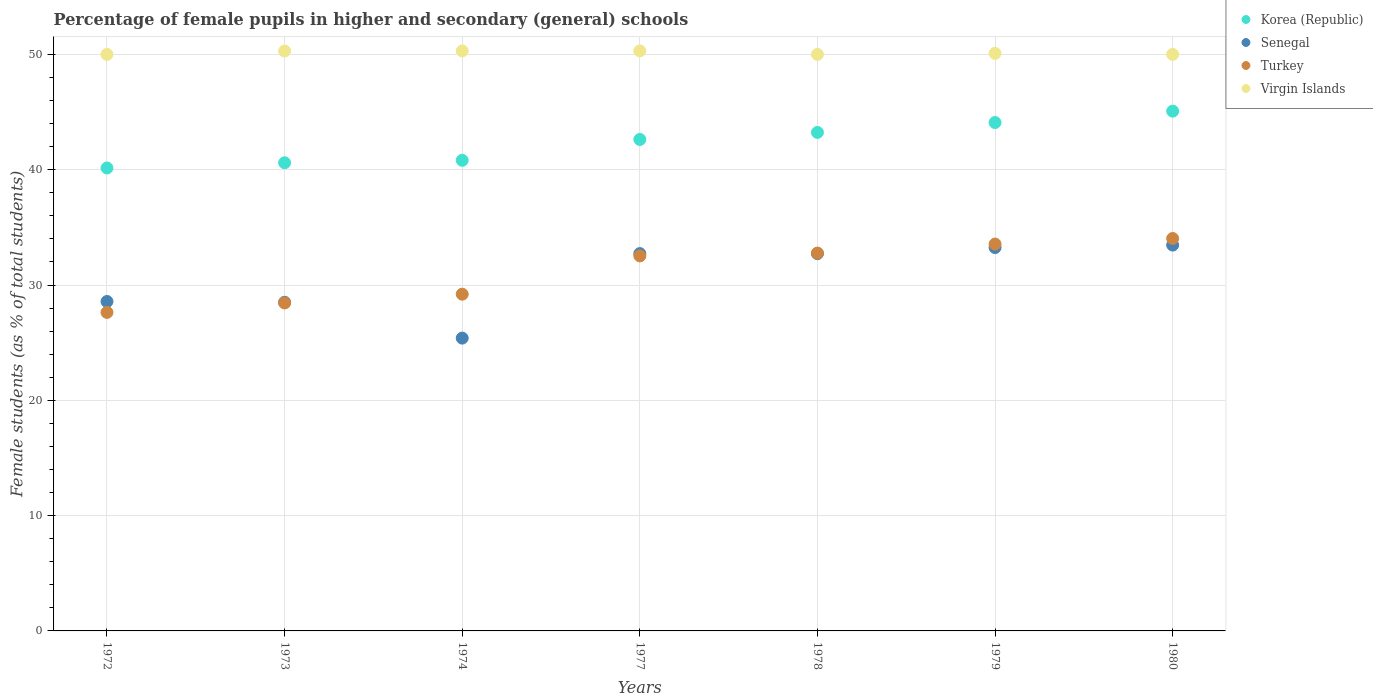What is the percentage of female pupils in higher and secondary schools in Korea (Republic) in 1980?
Your answer should be compact. 45.08. Across all years, what is the maximum percentage of female pupils in higher and secondary schools in Virgin Islands?
Make the answer very short. 50.3. Across all years, what is the minimum percentage of female pupils in higher and secondary schools in Turkey?
Keep it short and to the point. 27.62. In which year was the percentage of female pupils in higher and secondary schools in Virgin Islands maximum?
Your answer should be compact. 1977. In which year was the percentage of female pupils in higher and secondary schools in Senegal minimum?
Your response must be concise. 1974. What is the total percentage of female pupils in higher and secondary schools in Virgin Islands in the graph?
Provide a succinct answer. 350.99. What is the difference between the percentage of female pupils in higher and secondary schools in Turkey in 1974 and that in 1980?
Ensure brevity in your answer.  -4.83. What is the difference between the percentage of female pupils in higher and secondary schools in Senegal in 1978 and the percentage of female pupils in higher and secondary schools in Korea (Republic) in 1980?
Provide a short and direct response. -12.36. What is the average percentage of female pupils in higher and secondary schools in Senegal per year?
Ensure brevity in your answer.  30.66. In the year 1973, what is the difference between the percentage of female pupils in higher and secondary schools in Virgin Islands and percentage of female pupils in higher and secondary schools in Turkey?
Provide a succinct answer. 21.85. What is the ratio of the percentage of female pupils in higher and secondary schools in Senegal in 1973 to that in 1980?
Provide a short and direct response. 0.85. What is the difference between the highest and the second highest percentage of female pupils in higher and secondary schools in Turkey?
Ensure brevity in your answer.  0.48. What is the difference between the highest and the lowest percentage of female pupils in higher and secondary schools in Turkey?
Make the answer very short. 6.41. Does the percentage of female pupils in higher and secondary schools in Korea (Republic) monotonically increase over the years?
Your answer should be very brief. Yes. Is the percentage of female pupils in higher and secondary schools in Senegal strictly greater than the percentage of female pupils in higher and secondary schools in Turkey over the years?
Your answer should be very brief. No. Is the percentage of female pupils in higher and secondary schools in Turkey strictly less than the percentage of female pupils in higher and secondary schools in Senegal over the years?
Provide a short and direct response. No. How many dotlines are there?
Offer a very short reply. 4. How many years are there in the graph?
Offer a terse response. 7. Does the graph contain grids?
Your response must be concise. Yes. Where does the legend appear in the graph?
Provide a succinct answer. Top right. How many legend labels are there?
Your answer should be compact. 4. How are the legend labels stacked?
Your answer should be compact. Vertical. What is the title of the graph?
Offer a terse response. Percentage of female pupils in higher and secondary (general) schools. What is the label or title of the Y-axis?
Your response must be concise. Female students (as % of total students). What is the Female students (as % of total students) in Korea (Republic) in 1972?
Your response must be concise. 40.15. What is the Female students (as % of total students) of Senegal in 1972?
Offer a very short reply. 28.57. What is the Female students (as % of total students) of Turkey in 1972?
Provide a short and direct response. 27.62. What is the Female students (as % of total students) in Korea (Republic) in 1973?
Offer a very short reply. 40.6. What is the Female students (as % of total students) of Senegal in 1973?
Provide a succinct answer. 28.5. What is the Female students (as % of total students) of Turkey in 1973?
Offer a terse response. 28.45. What is the Female students (as % of total students) in Virgin Islands in 1973?
Your answer should be compact. 50.3. What is the Female students (as % of total students) of Korea (Republic) in 1974?
Offer a terse response. 40.82. What is the Female students (as % of total students) of Senegal in 1974?
Give a very brief answer. 25.39. What is the Female students (as % of total students) in Turkey in 1974?
Provide a short and direct response. 29.2. What is the Female students (as % of total students) of Virgin Islands in 1974?
Ensure brevity in your answer.  50.3. What is the Female students (as % of total students) in Korea (Republic) in 1977?
Offer a terse response. 42.62. What is the Female students (as % of total students) in Senegal in 1977?
Give a very brief answer. 32.72. What is the Female students (as % of total students) in Turkey in 1977?
Offer a terse response. 32.52. What is the Female students (as % of total students) in Virgin Islands in 1977?
Your response must be concise. 50.3. What is the Female students (as % of total students) in Korea (Republic) in 1978?
Keep it short and to the point. 43.23. What is the Female students (as % of total students) of Senegal in 1978?
Ensure brevity in your answer.  32.72. What is the Female students (as % of total students) in Turkey in 1978?
Your response must be concise. 32.77. What is the Female students (as % of total students) in Korea (Republic) in 1979?
Your answer should be very brief. 44.09. What is the Female students (as % of total students) in Senegal in 1979?
Your answer should be compact. 33.25. What is the Female students (as % of total students) of Turkey in 1979?
Keep it short and to the point. 33.55. What is the Female students (as % of total students) in Virgin Islands in 1979?
Your answer should be compact. 50.09. What is the Female students (as % of total students) in Korea (Republic) in 1980?
Ensure brevity in your answer.  45.08. What is the Female students (as % of total students) in Senegal in 1980?
Give a very brief answer. 33.46. What is the Female students (as % of total students) of Turkey in 1980?
Provide a short and direct response. 34.03. What is the Female students (as % of total students) of Virgin Islands in 1980?
Give a very brief answer. 50. Across all years, what is the maximum Female students (as % of total students) in Korea (Republic)?
Make the answer very short. 45.08. Across all years, what is the maximum Female students (as % of total students) in Senegal?
Ensure brevity in your answer.  33.46. Across all years, what is the maximum Female students (as % of total students) in Turkey?
Ensure brevity in your answer.  34.03. Across all years, what is the maximum Female students (as % of total students) of Virgin Islands?
Provide a short and direct response. 50.3. Across all years, what is the minimum Female students (as % of total students) of Korea (Republic)?
Keep it short and to the point. 40.15. Across all years, what is the minimum Female students (as % of total students) of Senegal?
Provide a short and direct response. 25.39. Across all years, what is the minimum Female students (as % of total students) in Turkey?
Your response must be concise. 27.62. What is the total Female students (as % of total students) of Korea (Republic) in the graph?
Offer a very short reply. 296.59. What is the total Female students (as % of total students) in Senegal in the graph?
Provide a short and direct response. 214.62. What is the total Female students (as % of total students) in Turkey in the graph?
Provide a short and direct response. 218.15. What is the total Female students (as % of total students) in Virgin Islands in the graph?
Ensure brevity in your answer.  350.99. What is the difference between the Female students (as % of total students) in Korea (Republic) in 1972 and that in 1973?
Your answer should be very brief. -0.45. What is the difference between the Female students (as % of total students) in Senegal in 1972 and that in 1973?
Offer a very short reply. 0.07. What is the difference between the Female students (as % of total students) in Turkey in 1972 and that in 1973?
Your answer should be very brief. -0.82. What is the difference between the Female students (as % of total students) of Virgin Islands in 1972 and that in 1973?
Provide a short and direct response. -0.3. What is the difference between the Female students (as % of total students) of Korea (Republic) in 1972 and that in 1974?
Offer a terse response. -0.67. What is the difference between the Female students (as % of total students) in Senegal in 1972 and that in 1974?
Keep it short and to the point. 3.18. What is the difference between the Female students (as % of total students) in Turkey in 1972 and that in 1974?
Give a very brief answer. -1.58. What is the difference between the Female students (as % of total students) in Virgin Islands in 1972 and that in 1974?
Keep it short and to the point. -0.3. What is the difference between the Female students (as % of total students) in Korea (Republic) in 1972 and that in 1977?
Ensure brevity in your answer.  -2.47. What is the difference between the Female students (as % of total students) of Senegal in 1972 and that in 1977?
Make the answer very short. -4.15. What is the difference between the Female students (as % of total students) of Turkey in 1972 and that in 1977?
Ensure brevity in your answer.  -4.9. What is the difference between the Female students (as % of total students) of Virgin Islands in 1972 and that in 1977?
Offer a very short reply. -0.3. What is the difference between the Female students (as % of total students) of Korea (Republic) in 1972 and that in 1978?
Offer a terse response. -3.08. What is the difference between the Female students (as % of total students) of Senegal in 1972 and that in 1978?
Your answer should be compact. -4.15. What is the difference between the Female students (as % of total students) of Turkey in 1972 and that in 1978?
Make the answer very short. -5.14. What is the difference between the Female students (as % of total students) of Korea (Republic) in 1972 and that in 1979?
Give a very brief answer. -3.94. What is the difference between the Female students (as % of total students) in Senegal in 1972 and that in 1979?
Your answer should be compact. -4.68. What is the difference between the Female students (as % of total students) in Turkey in 1972 and that in 1979?
Offer a very short reply. -5.93. What is the difference between the Female students (as % of total students) of Virgin Islands in 1972 and that in 1979?
Your response must be concise. -0.09. What is the difference between the Female students (as % of total students) of Korea (Republic) in 1972 and that in 1980?
Give a very brief answer. -4.93. What is the difference between the Female students (as % of total students) of Senegal in 1972 and that in 1980?
Provide a succinct answer. -4.89. What is the difference between the Female students (as % of total students) in Turkey in 1972 and that in 1980?
Your answer should be compact. -6.41. What is the difference between the Female students (as % of total students) of Korea (Republic) in 1973 and that in 1974?
Your response must be concise. -0.21. What is the difference between the Female students (as % of total students) of Senegal in 1973 and that in 1974?
Give a very brief answer. 3.11. What is the difference between the Female students (as % of total students) in Turkey in 1973 and that in 1974?
Offer a terse response. -0.76. What is the difference between the Female students (as % of total students) in Virgin Islands in 1973 and that in 1974?
Your response must be concise. -0. What is the difference between the Female students (as % of total students) of Korea (Republic) in 1973 and that in 1977?
Make the answer very short. -2.02. What is the difference between the Female students (as % of total students) of Senegal in 1973 and that in 1977?
Your response must be concise. -4.22. What is the difference between the Female students (as % of total students) in Turkey in 1973 and that in 1977?
Provide a succinct answer. -4.08. What is the difference between the Female students (as % of total students) of Virgin Islands in 1973 and that in 1977?
Make the answer very short. -0. What is the difference between the Female students (as % of total students) in Korea (Republic) in 1973 and that in 1978?
Provide a succinct answer. -2.63. What is the difference between the Female students (as % of total students) in Senegal in 1973 and that in 1978?
Keep it short and to the point. -4.22. What is the difference between the Female students (as % of total students) in Turkey in 1973 and that in 1978?
Offer a very short reply. -4.32. What is the difference between the Female students (as % of total students) of Virgin Islands in 1973 and that in 1978?
Offer a terse response. 0.3. What is the difference between the Female students (as % of total students) in Korea (Republic) in 1973 and that in 1979?
Your answer should be very brief. -3.49. What is the difference between the Female students (as % of total students) of Senegal in 1973 and that in 1979?
Your response must be concise. -4.75. What is the difference between the Female students (as % of total students) of Turkey in 1973 and that in 1979?
Offer a terse response. -5.11. What is the difference between the Female students (as % of total students) in Virgin Islands in 1973 and that in 1979?
Provide a succinct answer. 0.2. What is the difference between the Female students (as % of total students) of Korea (Republic) in 1973 and that in 1980?
Ensure brevity in your answer.  -4.48. What is the difference between the Female students (as % of total students) of Senegal in 1973 and that in 1980?
Your response must be concise. -4.96. What is the difference between the Female students (as % of total students) of Turkey in 1973 and that in 1980?
Give a very brief answer. -5.59. What is the difference between the Female students (as % of total students) in Virgin Islands in 1973 and that in 1980?
Keep it short and to the point. 0.3. What is the difference between the Female students (as % of total students) in Korea (Republic) in 1974 and that in 1977?
Your answer should be very brief. -1.81. What is the difference between the Female students (as % of total students) of Senegal in 1974 and that in 1977?
Offer a very short reply. -7.33. What is the difference between the Female students (as % of total students) of Turkey in 1974 and that in 1977?
Keep it short and to the point. -3.32. What is the difference between the Female students (as % of total students) of Virgin Islands in 1974 and that in 1977?
Give a very brief answer. -0. What is the difference between the Female students (as % of total students) of Korea (Republic) in 1974 and that in 1978?
Provide a short and direct response. -2.42. What is the difference between the Female students (as % of total students) in Senegal in 1974 and that in 1978?
Offer a terse response. -7.33. What is the difference between the Female students (as % of total students) of Turkey in 1974 and that in 1978?
Ensure brevity in your answer.  -3.56. What is the difference between the Female students (as % of total students) in Virgin Islands in 1974 and that in 1978?
Your response must be concise. 0.3. What is the difference between the Female students (as % of total students) of Korea (Republic) in 1974 and that in 1979?
Make the answer very short. -3.28. What is the difference between the Female students (as % of total students) in Senegal in 1974 and that in 1979?
Provide a succinct answer. -7.85. What is the difference between the Female students (as % of total students) in Turkey in 1974 and that in 1979?
Your response must be concise. -4.35. What is the difference between the Female students (as % of total students) of Virgin Islands in 1974 and that in 1979?
Offer a terse response. 0.21. What is the difference between the Female students (as % of total students) of Korea (Republic) in 1974 and that in 1980?
Ensure brevity in your answer.  -4.26. What is the difference between the Female students (as % of total students) of Senegal in 1974 and that in 1980?
Ensure brevity in your answer.  -8.07. What is the difference between the Female students (as % of total students) of Turkey in 1974 and that in 1980?
Keep it short and to the point. -4.83. What is the difference between the Female students (as % of total students) in Virgin Islands in 1974 and that in 1980?
Offer a very short reply. 0.3. What is the difference between the Female students (as % of total students) in Korea (Republic) in 1977 and that in 1978?
Offer a very short reply. -0.61. What is the difference between the Female students (as % of total students) in Senegal in 1977 and that in 1978?
Keep it short and to the point. 0. What is the difference between the Female students (as % of total students) in Turkey in 1977 and that in 1978?
Offer a very short reply. -0.24. What is the difference between the Female students (as % of total students) in Virgin Islands in 1977 and that in 1978?
Make the answer very short. 0.3. What is the difference between the Female students (as % of total students) of Korea (Republic) in 1977 and that in 1979?
Give a very brief answer. -1.47. What is the difference between the Female students (as % of total students) in Senegal in 1977 and that in 1979?
Your answer should be compact. -0.53. What is the difference between the Female students (as % of total students) of Turkey in 1977 and that in 1979?
Your answer should be compact. -1.03. What is the difference between the Female students (as % of total students) of Virgin Islands in 1977 and that in 1979?
Keep it short and to the point. 0.21. What is the difference between the Female students (as % of total students) in Korea (Republic) in 1977 and that in 1980?
Your answer should be compact. -2.46. What is the difference between the Female students (as % of total students) in Senegal in 1977 and that in 1980?
Your answer should be compact. -0.74. What is the difference between the Female students (as % of total students) in Turkey in 1977 and that in 1980?
Offer a terse response. -1.51. What is the difference between the Female students (as % of total students) of Virgin Islands in 1977 and that in 1980?
Your answer should be very brief. 0.3. What is the difference between the Female students (as % of total students) of Korea (Republic) in 1978 and that in 1979?
Offer a very short reply. -0.86. What is the difference between the Female students (as % of total students) of Senegal in 1978 and that in 1979?
Your answer should be very brief. -0.53. What is the difference between the Female students (as % of total students) of Turkey in 1978 and that in 1979?
Make the answer very short. -0.79. What is the difference between the Female students (as % of total students) of Virgin Islands in 1978 and that in 1979?
Provide a short and direct response. -0.09. What is the difference between the Female students (as % of total students) of Korea (Republic) in 1978 and that in 1980?
Provide a succinct answer. -1.85. What is the difference between the Female students (as % of total students) in Senegal in 1978 and that in 1980?
Provide a succinct answer. -0.74. What is the difference between the Female students (as % of total students) in Turkey in 1978 and that in 1980?
Keep it short and to the point. -1.27. What is the difference between the Female students (as % of total students) of Virgin Islands in 1978 and that in 1980?
Make the answer very short. 0. What is the difference between the Female students (as % of total students) in Korea (Republic) in 1979 and that in 1980?
Give a very brief answer. -0.99. What is the difference between the Female students (as % of total students) of Senegal in 1979 and that in 1980?
Give a very brief answer. -0.21. What is the difference between the Female students (as % of total students) in Turkey in 1979 and that in 1980?
Offer a very short reply. -0.48. What is the difference between the Female students (as % of total students) of Virgin Islands in 1979 and that in 1980?
Provide a short and direct response. 0.09. What is the difference between the Female students (as % of total students) of Korea (Republic) in 1972 and the Female students (as % of total students) of Senegal in 1973?
Your answer should be very brief. 11.65. What is the difference between the Female students (as % of total students) of Korea (Republic) in 1972 and the Female students (as % of total students) of Turkey in 1973?
Offer a terse response. 11.7. What is the difference between the Female students (as % of total students) of Korea (Republic) in 1972 and the Female students (as % of total students) of Virgin Islands in 1973?
Your answer should be very brief. -10.15. What is the difference between the Female students (as % of total students) of Senegal in 1972 and the Female students (as % of total students) of Turkey in 1973?
Your response must be concise. 0.12. What is the difference between the Female students (as % of total students) in Senegal in 1972 and the Female students (as % of total students) in Virgin Islands in 1973?
Your response must be concise. -21.73. What is the difference between the Female students (as % of total students) in Turkey in 1972 and the Female students (as % of total students) in Virgin Islands in 1973?
Your answer should be very brief. -22.67. What is the difference between the Female students (as % of total students) of Korea (Republic) in 1972 and the Female students (as % of total students) of Senegal in 1974?
Keep it short and to the point. 14.76. What is the difference between the Female students (as % of total students) of Korea (Republic) in 1972 and the Female students (as % of total students) of Turkey in 1974?
Provide a succinct answer. 10.94. What is the difference between the Female students (as % of total students) of Korea (Republic) in 1972 and the Female students (as % of total students) of Virgin Islands in 1974?
Make the answer very short. -10.15. What is the difference between the Female students (as % of total students) in Senegal in 1972 and the Female students (as % of total students) in Turkey in 1974?
Offer a very short reply. -0.64. What is the difference between the Female students (as % of total students) of Senegal in 1972 and the Female students (as % of total students) of Virgin Islands in 1974?
Keep it short and to the point. -21.73. What is the difference between the Female students (as % of total students) of Turkey in 1972 and the Female students (as % of total students) of Virgin Islands in 1974?
Offer a terse response. -22.68. What is the difference between the Female students (as % of total students) of Korea (Republic) in 1972 and the Female students (as % of total students) of Senegal in 1977?
Provide a succinct answer. 7.43. What is the difference between the Female students (as % of total students) of Korea (Republic) in 1972 and the Female students (as % of total students) of Turkey in 1977?
Provide a short and direct response. 7.63. What is the difference between the Female students (as % of total students) of Korea (Republic) in 1972 and the Female students (as % of total students) of Virgin Islands in 1977?
Your response must be concise. -10.15. What is the difference between the Female students (as % of total students) in Senegal in 1972 and the Female students (as % of total students) in Turkey in 1977?
Make the answer very short. -3.96. What is the difference between the Female students (as % of total students) in Senegal in 1972 and the Female students (as % of total students) in Virgin Islands in 1977?
Your response must be concise. -21.73. What is the difference between the Female students (as % of total students) of Turkey in 1972 and the Female students (as % of total students) of Virgin Islands in 1977?
Your response must be concise. -22.68. What is the difference between the Female students (as % of total students) of Korea (Republic) in 1972 and the Female students (as % of total students) of Senegal in 1978?
Make the answer very short. 7.43. What is the difference between the Female students (as % of total students) of Korea (Republic) in 1972 and the Female students (as % of total students) of Turkey in 1978?
Make the answer very short. 7.38. What is the difference between the Female students (as % of total students) of Korea (Republic) in 1972 and the Female students (as % of total students) of Virgin Islands in 1978?
Ensure brevity in your answer.  -9.85. What is the difference between the Female students (as % of total students) in Senegal in 1972 and the Female students (as % of total students) in Turkey in 1978?
Give a very brief answer. -4.2. What is the difference between the Female students (as % of total students) of Senegal in 1972 and the Female students (as % of total students) of Virgin Islands in 1978?
Your answer should be compact. -21.43. What is the difference between the Female students (as % of total students) in Turkey in 1972 and the Female students (as % of total students) in Virgin Islands in 1978?
Your answer should be very brief. -22.38. What is the difference between the Female students (as % of total students) of Korea (Republic) in 1972 and the Female students (as % of total students) of Senegal in 1979?
Make the answer very short. 6.9. What is the difference between the Female students (as % of total students) in Korea (Republic) in 1972 and the Female students (as % of total students) in Turkey in 1979?
Offer a terse response. 6.6. What is the difference between the Female students (as % of total students) of Korea (Republic) in 1972 and the Female students (as % of total students) of Virgin Islands in 1979?
Give a very brief answer. -9.94. What is the difference between the Female students (as % of total students) of Senegal in 1972 and the Female students (as % of total students) of Turkey in 1979?
Ensure brevity in your answer.  -4.98. What is the difference between the Female students (as % of total students) of Senegal in 1972 and the Female students (as % of total students) of Virgin Islands in 1979?
Your answer should be very brief. -21.52. What is the difference between the Female students (as % of total students) of Turkey in 1972 and the Female students (as % of total students) of Virgin Islands in 1979?
Your answer should be compact. -22.47. What is the difference between the Female students (as % of total students) in Korea (Republic) in 1972 and the Female students (as % of total students) in Senegal in 1980?
Ensure brevity in your answer.  6.69. What is the difference between the Female students (as % of total students) in Korea (Republic) in 1972 and the Female students (as % of total students) in Turkey in 1980?
Provide a short and direct response. 6.12. What is the difference between the Female students (as % of total students) in Korea (Republic) in 1972 and the Female students (as % of total students) in Virgin Islands in 1980?
Your response must be concise. -9.85. What is the difference between the Female students (as % of total students) of Senegal in 1972 and the Female students (as % of total students) of Turkey in 1980?
Offer a terse response. -5.46. What is the difference between the Female students (as % of total students) of Senegal in 1972 and the Female students (as % of total students) of Virgin Islands in 1980?
Offer a very short reply. -21.43. What is the difference between the Female students (as % of total students) in Turkey in 1972 and the Female students (as % of total students) in Virgin Islands in 1980?
Your answer should be very brief. -22.38. What is the difference between the Female students (as % of total students) of Korea (Republic) in 1973 and the Female students (as % of total students) of Senegal in 1974?
Give a very brief answer. 15.21. What is the difference between the Female students (as % of total students) of Korea (Republic) in 1973 and the Female students (as % of total students) of Turkey in 1974?
Provide a short and direct response. 11.4. What is the difference between the Female students (as % of total students) in Korea (Republic) in 1973 and the Female students (as % of total students) in Virgin Islands in 1974?
Keep it short and to the point. -9.7. What is the difference between the Female students (as % of total students) of Senegal in 1973 and the Female students (as % of total students) of Turkey in 1974?
Your answer should be very brief. -0.7. What is the difference between the Female students (as % of total students) in Senegal in 1973 and the Female students (as % of total students) in Virgin Islands in 1974?
Your answer should be compact. -21.8. What is the difference between the Female students (as % of total students) in Turkey in 1973 and the Female students (as % of total students) in Virgin Islands in 1974?
Ensure brevity in your answer.  -21.85. What is the difference between the Female students (as % of total students) in Korea (Republic) in 1973 and the Female students (as % of total students) in Senegal in 1977?
Ensure brevity in your answer.  7.88. What is the difference between the Female students (as % of total students) in Korea (Republic) in 1973 and the Female students (as % of total students) in Turkey in 1977?
Offer a very short reply. 8.08. What is the difference between the Female students (as % of total students) in Korea (Republic) in 1973 and the Female students (as % of total students) in Virgin Islands in 1977?
Provide a short and direct response. -9.7. What is the difference between the Female students (as % of total students) of Senegal in 1973 and the Female students (as % of total students) of Turkey in 1977?
Keep it short and to the point. -4.02. What is the difference between the Female students (as % of total students) in Senegal in 1973 and the Female students (as % of total students) in Virgin Islands in 1977?
Offer a very short reply. -21.8. What is the difference between the Female students (as % of total students) in Turkey in 1973 and the Female students (as % of total students) in Virgin Islands in 1977?
Your answer should be very brief. -21.85. What is the difference between the Female students (as % of total students) in Korea (Republic) in 1973 and the Female students (as % of total students) in Senegal in 1978?
Ensure brevity in your answer.  7.88. What is the difference between the Female students (as % of total students) in Korea (Republic) in 1973 and the Female students (as % of total students) in Turkey in 1978?
Offer a terse response. 7.83. What is the difference between the Female students (as % of total students) of Korea (Republic) in 1973 and the Female students (as % of total students) of Virgin Islands in 1978?
Your answer should be very brief. -9.4. What is the difference between the Female students (as % of total students) in Senegal in 1973 and the Female students (as % of total students) in Turkey in 1978?
Make the answer very short. -4.26. What is the difference between the Female students (as % of total students) of Senegal in 1973 and the Female students (as % of total students) of Virgin Islands in 1978?
Your answer should be compact. -21.5. What is the difference between the Female students (as % of total students) of Turkey in 1973 and the Female students (as % of total students) of Virgin Islands in 1978?
Keep it short and to the point. -21.55. What is the difference between the Female students (as % of total students) in Korea (Republic) in 1973 and the Female students (as % of total students) in Senegal in 1979?
Your answer should be very brief. 7.35. What is the difference between the Female students (as % of total students) of Korea (Republic) in 1973 and the Female students (as % of total students) of Turkey in 1979?
Provide a succinct answer. 7.05. What is the difference between the Female students (as % of total students) of Korea (Republic) in 1973 and the Female students (as % of total students) of Virgin Islands in 1979?
Your answer should be compact. -9.49. What is the difference between the Female students (as % of total students) of Senegal in 1973 and the Female students (as % of total students) of Turkey in 1979?
Make the answer very short. -5.05. What is the difference between the Female students (as % of total students) of Senegal in 1973 and the Female students (as % of total students) of Virgin Islands in 1979?
Your response must be concise. -21.59. What is the difference between the Female students (as % of total students) in Turkey in 1973 and the Female students (as % of total students) in Virgin Islands in 1979?
Your answer should be very brief. -21.65. What is the difference between the Female students (as % of total students) in Korea (Republic) in 1973 and the Female students (as % of total students) in Senegal in 1980?
Your answer should be very brief. 7.14. What is the difference between the Female students (as % of total students) of Korea (Republic) in 1973 and the Female students (as % of total students) of Turkey in 1980?
Make the answer very short. 6.57. What is the difference between the Female students (as % of total students) of Korea (Republic) in 1973 and the Female students (as % of total students) of Virgin Islands in 1980?
Keep it short and to the point. -9.4. What is the difference between the Female students (as % of total students) of Senegal in 1973 and the Female students (as % of total students) of Turkey in 1980?
Provide a short and direct response. -5.53. What is the difference between the Female students (as % of total students) of Senegal in 1973 and the Female students (as % of total students) of Virgin Islands in 1980?
Provide a short and direct response. -21.5. What is the difference between the Female students (as % of total students) in Turkey in 1973 and the Female students (as % of total students) in Virgin Islands in 1980?
Your answer should be compact. -21.55. What is the difference between the Female students (as % of total students) in Korea (Republic) in 1974 and the Female students (as % of total students) in Senegal in 1977?
Offer a terse response. 8.09. What is the difference between the Female students (as % of total students) in Korea (Republic) in 1974 and the Female students (as % of total students) in Turkey in 1977?
Your answer should be compact. 8.29. What is the difference between the Female students (as % of total students) in Korea (Republic) in 1974 and the Female students (as % of total students) in Virgin Islands in 1977?
Offer a very short reply. -9.49. What is the difference between the Female students (as % of total students) of Senegal in 1974 and the Female students (as % of total students) of Turkey in 1977?
Your response must be concise. -7.13. What is the difference between the Female students (as % of total students) in Senegal in 1974 and the Female students (as % of total students) in Virgin Islands in 1977?
Your answer should be compact. -24.91. What is the difference between the Female students (as % of total students) in Turkey in 1974 and the Female students (as % of total students) in Virgin Islands in 1977?
Provide a succinct answer. -21.1. What is the difference between the Female students (as % of total students) in Korea (Republic) in 1974 and the Female students (as % of total students) in Senegal in 1978?
Your response must be concise. 8.1. What is the difference between the Female students (as % of total students) of Korea (Republic) in 1974 and the Female students (as % of total students) of Turkey in 1978?
Offer a very short reply. 8.05. What is the difference between the Female students (as % of total students) of Korea (Republic) in 1974 and the Female students (as % of total students) of Virgin Islands in 1978?
Make the answer very short. -9.18. What is the difference between the Female students (as % of total students) of Senegal in 1974 and the Female students (as % of total students) of Turkey in 1978?
Your response must be concise. -7.37. What is the difference between the Female students (as % of total students) of Senegal in 1974 and the Female students (as % of total students) of Virgin Islands in 1978?
Provide a short and direct response. -24.61. What is the difference between the Female students (as % of total students) in Turkey in 1974 and the Female students (as % of total students) in Virgin Islands in 1978?
Your answer should be very brief. -20.8. What is the difference between the Female students (as % of total students) in Korea (Republic) in 1974 and the Female students (as % of total students) in Senegal in 1979?
Make the answer very short. 7.57. What is the difference between the Female students (as % of total students) of Korea (Republic) in 1974 and the Female students (as % of total students) of Turkey in 1979?
Provide a succinct answer. 7.26. What is the difference between the Female students (as % of total students) of Korea (Republic) in 1974 and the Female students (as % of total students) of Virgin Islands in 1979?
Your answer should be compact. -9.28. What is the difference between the Female students (as % of total students) in Senegal in 1974 and the Female students (as % of total students) in Turkey in 1979?
Offer a very short reply. -8.16. What is the difference between the Female students (as % of total students) in Senegal in 1974 and the Female students (as % of total students) in Virgin Islands in 1979?
Provide a succinct answer. -24.7. What is the difference between the Female students (as % of total students) in Turkey in 1974 and the Female students (as % of total students) in Virgin Islands in 1979?
Your response must be concise. -20.89. What is the difference between the Female students (as % of total students) in Korea (Republic) in 1974 and the Female students (as % of total students) in Senegal in 1980?
Keep it short and to the point. 7.35. What is the difference between the Female students (as % of total students) of Korea (Republic) in 1974 and the Female students (as % of total students) of Turkey in 1980?
Make the answer very short. 6.78. What is the difference between the Female students (as % of total students) of Korea (Republic) in 1974 and the Female students (as % of total students) of Virgin Islands in 1980?
Make the answer very short. -9.18. What is the difference between the Female students (as % of total students) of Senegal in 1974 and the Female students (as % of total students) of Turkey in 1980?
Give a very brief answer. -8.64. What is the difference between the Female students (as % of total students) in Senegal in 1974 and the Female students (as % of total students) in Virgin Islands in 1980?
Offer a terse response. -24.61. What is the difference between the Female students (as % of total students) in Turkey in 1974 and the Female students (as % of total students) in Virgin Islands in 1980?
Keep it short and to the point. -20.8. What is the difference between the Female students (as % of total students) in Korea (Republic) in 1977 and the Female students (as % of total students) in Senegal in 1978?
Your response must be concise. 9.9. What is the difference between the Female students (as % of total students) of Korea (Republic) in 1977 and the Female students (as % of total students) of Turkey in 1978?
Offer a terse response. 9.86. What is the difference between the Female students (as % of total students) of Korea (Republic) in 1977 and the Female students (as % of total students) of Virgin Islands in 1978?
Offer a very short reply. -7.38. What is the difference between the Female students (as % of total students) in Senegal in 1977 and the Female students (as % of total students) in Turkey in 1978?
Provide a succinct answer. -0.04. What is the difference between the Female students (as % of total students) of Senegal in 1977 and the Female students (as % of total students) of Virgin Islands in 1978?
Your answer should be very brief. -17.28. What is the difference between the Female students (as % of total students) of Turkey in 1977 and the Female students (as % of total students) of Virgin Islands in 1978?
Make the answer very short. -17.48. What is the difference between the Female students (as % of total students) in Korea (Republic) in 1977 and the Female students (as % of total students) in Senegal in 1979?
Keep it short and to the point. 9.37. What is the difference between the Female students (as % of total students) in Korea (Republic) in 1977 and the Female students (as % of total students) in Turkey in 1979?
Offer a terse response. 9.07. What is the difference between the Female students (as % of total students) in Korea (Republic) in 1977 and the Female students (as % of total students) in Virgin Islands in 1979?
Make the answer very short. -7.47. What is the difference between the Female students (as % of total students) of Senegal in 1977 and the Female students (as % of total students) of Turkey in 1979?
Give a very brief answer. -0.83. What is the difference between the Female students (as % of total students) in Senegal in 1977 and the Female students (as % of total students) in Virgin Islands in 1979?
Make the answer very short. -17.37. What is the difference between the Female students (as % of total students) in Turkey in 1977 and the Female students (as % of total students) in Virgin Islands in 1979?
Ensure brevity in your answer.  -17.57. What is the difference between the Female students (as % of total students) in Korea (Republic) in 1977 and the Female students (as % of total students) in Senegal in 1980?
Offer a terse response. 9.16. What is the difference between the Female students (as % of total students) in Korea (Republic) in 1977 and the Female students (as % of total students) in Turkey in 1980?
Offer a terse response. 8.59. What is the difference between the Female students (as % of total students) of Korea (Republic) in 1977 and the Female students (as % of total students) of Virgin Islands in 1980?
Your answer should be very brief. -7.38. What is the difference between the Female students (as % of total students) of Senegal in 1977 and the Female students (as % of total students) of Turkey in 1980?
Keep it short and to the point. -1.31. What is the difference between the Female students (as % of total students) of Senegal in 1977 and the Female students (as % of total students) of Virgin Islands in 1980?
Your answer should be compact. -17.28. What is the difference between the Female students (as % of total students) in Turkey in 1977 and the Female students (as % of total students) in Virgin Islands in 1980?
Your response must be concise. -17.48. What is the difference between the Female students (as % of total students) in Korea (Republic) in 1978 and the Female students (as % of total students) in Senegal in 1979?
Offer a very short reply. 9.98. What is the difference between the Female students (as % of total students) of Korea (Republic) in 1978 and the Female students (as % of total students) of Turkey in 1979?
Provide a succinct answer. 9.68. What is the difference between the Female students (as % of total students) in Korea (Republic) in 1978 and the Female students (as % of total students) in Virgin Islands in 1979?
Give a very brief answer. -6.86. What is the difference between the Female students (as % of total students) of Senegal in 1978 and the Female students (as % of total students) of Turkey in 1979?
Ensure brevity in your answer.  -0.83. What is the difference between the Female students (as % of total students) in Senegal in 1978 and the Female students (as % of total students) in Virgin Islands in 1979?
Keep it short and to the point. -17.37. What is the difference between the Female students (as % of total students) in Turkey in 1978 and the Female students (as % of total students) in Virgin Islands in 1979?
Keep it short and to the point. -17.33. What is the difference between the Female students (as % of total students) in Korea (Republic) in 1978 and the Female students (as % of total students) in Senegal in 1980?
Your response must be concise. 9.77. What is the difference between the Female students (as % of total students) in Korea (Republic) in 1978 and the Female students (as % of total students) in Turkey in 1980?
Keep it short and to the point. 9.2. What is the difference between the Female students (as % of total students) of Korea (Republic) in 1978 and the Female students (as % of total students) of Virgin Islands in 1980?
Provide a short and direct response. -6.77. What is the difference between the Female students (as % of total students) of Senegal in 1978 and the Female students (as % of total students) of Turkey in 1980?
Offer a very short reply. -1.31. What is the difference between the Female students (as % of total students) in Senegal in 1978 and the Female students (as % of total students) in Virgin Islands in 1980?
Your answer should be compact. -17.28. What is the difference between the Female students (as % of total students) in Turkey in 1978 and the Female students (as % of total students) in Virgin Islands in 1980?
Ensure brevity in your answer.  -17.23. What is the difference between the Female students (as % of total students) of Korea (Republic) in 1979 and the Female students (as % of total students) of Senegal in 1980?
Your answer should be compact. 10.63. What is the difference between the Female students (as % of total students) of Korea (Republic) in 1979 and the Female students (as % of total students) of Turkey in 1980?
Give a very brief answer. 10.06. What is the difference between the Female students (as % of total students) in Korea (Republic) in 1979 and the Female students (as % of total students) in Virgin Islands in 1980?
Give a very brief answer. -5.91. What is the difference between the Female students (as % of total students) of Senegal in 1979 and the Female students (as % of total students) of Turkey in 1980?
Provide a succinct answer. -0.79. What is the difference between the Female students (as % of total students) of Senegal in 1979 and the Female students (as % of total students) of Virgin Islands in 1980?
Your answer should be very brief. -16.75. What is the difference between the Female students (as % of total students) in Turkey in 1979 and the Female students (as % of total students) in Virgin Islands in 1980?
Provide a succinct answer. -16.45. What is the average Female students (as % of total students) in Korea (Republic) per year?
Give a very brief answer. 42.37. What is the average Female students (as % of total students) in Senegal per year?
Ensure brevity in your answer.  30.66. What is the average Female students (as % of total students) in Turkey per year?
Offer a very short reply. 31.16. What is the average Female students (as % of total students) in Virgin Islands per year?
Your response must be concise. 50.14. In the year 1972, what is the difference between the Female students (as % of total students) of Korea (Republic) and Female students (as % of total students) of Senegal?
Give a very brief answer. 11.58. In the year 1972, what is the difference between the Female students (as % of total students) in Korea (Republic) and Female students (as % of total students) in Turkey?
Keep it short and to the point. 12.53. In the year 1972, what is the difference between the Female students (as % of total students) of Korea (Republic) and Female students (as % of total students) of Virgin Islands?
Your response must be concise. -9.85. In the year 1972, what is the difference between the Female students (as % of total students) in Senegal and Female students (as % of total students) in Turkey?
Your answer should be compact. 0.94. In the year 1972, what is the difference between the Female students (as % of total students) of Senegal and Female students (as % of total students) of Virgin Islands?
Ensure brevity in your answer.  -21.43. In the year 1972, what is the difference between the Female students (as % of total students) in Turkey and Female students (as % of total students) in Virgin Islands?
Your response must be concise. -22.38. In the year 1973, what is the difference between the Female students (as % of total students) in Korea (Republic) and Female students (as % of total students) in Senegal?
Provide a short and direct response. 12.1. In the year 1973, what is the difference between the Female students (as % of total students) of Korea (Republic) and Female students (as % of total students) of Turkey?
Your answer should be compact. 12.15. In the year 1973, what is the difference between the Female students (as % of total students) of Korea (Republic) and Female students (as % of total students) of Virgin Islands?
Keep it short and to the point. -9.7. In the year 1973, what is the difference between the Female students (as % of total students) in Senegal and Female students (as % of total students) in Turkey?
Your response must be concise. 0.06. In the year 1973, what is the difference between the Female students (as % of total students) in Senegal and Female students (as % of total students) in Virgin Islands?
Make the answer very short. -21.79. In the year 1973, what is the difference between the Female students (as % of total students) in Turkey and Female students (as % of total students) in Virgin Islands?
Offer a terse response. -21.85. In the year 1974, what is the difference between the Female students (as % of total students) in Korea (Republic) and Female students (as % of total students) in Senegal?
Your response must be concise. 15.42. In the year 1974, what is the difference between the Female students (as % of total students) in Korea (Republic) and Female students (as % of total students) in Turkey?
Your response must be concise. 11.61. In the year 1974, what is the difference between the Female students (as % of total students) in Korea (Republic) and Female students (as % of total students) in Virgin Islands?
Provide a succinct answer. -9.48. In the year 1974, what is the difference between the Female students (as % of total students) of Senegal and Female students (as % of total students) of Turkey?
Provide a short and direct response. -3.81. In the year 1974, what is the difference between the Female students (as % of total students) of Senegal and Female students (as % of total students) of Virgin Islands?
Your response must be concise. -24.91. In the year 1974, what is the difference between the Female students (as % of total students) of Turkey and Female students (as % of total students) of Virgin Islands?
Provide a succinct answer. -21.09. In the year 1977, what is the difference between the Female students (as % of total students) in Korea (Republic) and Female students (as % of total students) in Senegal?
Ensure brevity in your answer.  9.9. In the year 1977, what is the difference between the Female students (as % of total students) of Korea (Republic) and Female students (as % of total students) of Turkey?
Keep it short and to the point. 10.1. In the year 1977, what is the difference between the Female students (as % of total students) of Korea (Republic) and Female students (as % of total students) of Virgin Islands?
Provide a short and direct response. -7.68. In the year 1977, what is the difference between the Female students (as % of total students) in Senegal and Female students (as % of total students) in Turkey?
Keep it short and to the point. 0.2. In the year 1977, what is the difference between the Female students (as % of total students) of Senegal and Female students (as % of total students) of Virgin Islands?
Provide a short and direct response. -17.58. In the year 1977, what is the difference between the Female students (as % of total students) of Turkey and Female students (as % of total students) of Virgin Islands?
Provide a succinct answer. -17.78. In the year 1978, what is the difference between the Female students (as % of total students) in Korea (Republic) and Female students (as % of total students) in Senegal?
Ensure brevity in your answer.  10.51. In the year 1978, what is the difference between the Female students (as % of total students) of Korea (Republic) and Female students (as % of total students) of Turkey?
Your answer should be very brief. 10.47. In the year 1978, what is the difference between the Female students (as % of total students) of Korea (Republic) and Female students (as % of total students) of Virgin Islands?
Provide a succinct answer. -6.77. In the year 1978, what is the difference between the Female students (as % of total students) of Senegal and Female students (as % of total students) of Turkey?
Provide a succinct answer. -0.05. In the year 1978, what is the difference between the Female students (as % of total students) of Senegal and Female students (as % of total students) of Virgin Islands?
Provide a succinct answer. -17.28. In the year 1978, what is the difference between the Female students (as % of total students) of Turkey and Female students (as % of total students) of Virgin Islands?
Your answer should be compact. -17.23. In the year 1979, what is the difference between the Female students (as % of total students) of Korea (Republic) and Female students (as % of total students) of Senegal?
Offer a terse response. 10.84. In the year 1979, what is the difference between the Female students (as % of total students) in Korea (Republic) and Female students (as % of total students) in Turkey?
Your answer should be very brief. 10.54. In the year 1979, what is the difference between the Female students (as % of total students) in Korea (Republic) and Female students (as % of total students) in Virgin Islands?
Give a very brief answer. -6. In the year 1979, what is the difference between the Female students (as % of total students) in Senegal and Female students (as % of total students) in Turkey?
Provide a succinct answer. -0.3. In the year 1979, what is the difference between the Female students (as % of total students) of Senegal and Female students (as % of total students) of Virgin Islands?
Your response must be concise. -16.84. In the year 1979, what is the difference between the Female students (as % of total students) in Turkey and Female students (as % of total students) in Virgin Islands?
Provide a short and direct response. -16.54. In the year 1980, what is the difference between the Female students (as % of total students) of Korea (Republic) and Female students (as % of total students) of Senegal?
Keep it short and to the point. 11.62. In the year 1980, what is the difference between the Female students (as % of total students) in Korea (Republic) and Female students (as % of total students) in Turkey?
Offer a very short reply. 11.04. In the year 1980, what is the difference between the Female students (as % of total students) of Korea (Republic) and Female students (as % of total students) of Virgin Islands?
Provide a short and direct response. -4.92. In the year 1980, what is the difference between the Female students (as % of total students) of Senegal and Female students (as % of total students) of Turkey?
Make the answer very short. -0.57. In the year 1980, what is the difference between the Female students (as % of total students) in Senegal and Female students (as % of total students) in Virgin Islands?
Provide a short and direct response. -16.54. In the year 1980, what is the difference between the Female students (as % of total students) in Turkey and Female students (as % of total students) in Virgin Islands?
Your response must be concise. -15.97. What is the ratio of the Female students (as % of total students) in Korea (Republic) in 1972 to that in 1973?
Your response must be concise. 0.99. What is the ratio of the Female students (as % of total students) in Senegal in 1972 to that in 1973?
Make the answer very short. 1. What is the ratio of the Female students (as % of total students) in Turkey in 1972 to that in 1973?
Keep it short and to the point. 0.97. What is the ratio of the Female students (as % of total students) in Virgin Islands in 1972 to that in 1973?
Provide a short and direct response. 0.99. What is the ratio of the Female students (as % of total students) of Korea (Republic) in 1972 to that in 1974?
Make the answer very short. 0.98. What is the ratio of the Female students (as % of total students) of Turkey in 1972 to that in 1974?
Provide a succinct answer. 0.95. What is the ratio of the Female students (as % of total students) of Korea (Republic) in 1972 to that in 1977?
Provide a short and direct response. 0.94. What is the ratio of the Female students (as % of total students) in Senegal in 1972 to that in 1977?
Provide a short and direct response. 0.87. What is the ratio of the Female students (as % of total students) of Turkey in 1972 to that in 1977?
Provide a succinct answer. 0.85. What is the ratio of the Female students (as % of total students) of Virgin Islands in 1972 to that in 1977?
Provide a short and direct response. 0.99. What is the ratio of the Female students (as % of total students) of Korea (Republic) in 1972 to that in 1978?
Your response must be concise. 0.93. What is the ratio of the Female students (as % of total students) in Senegal in 1972 to that in 1978?
Your answer should be compact. 0.87. What is the ratio of the Female students (as % of total students) of Turkey in 1972 to that in 1978?
Provide a succinct answer. 0.84. What is the ratio of the Female students (as % of total students) of Korea (Republic) in 1972 to that in 1979?
Provide a short and direct response. 0.91. What is the ratio of the Female students (as % of total students) of Senegal in 1972 to that in 1979?
Give a very brief answer. 0.86. What is the ratio of the Female students (as % of total students) in Turkey in 1972 to that in 1979?
Provide a succinct answer. 0.82. What is the ratio of the Female students (as % of total students) of Korea (Republic) in 1972 to that in 1980?
Provide a short and direct response. 0.89. What is the ratio of the Female students (as % of total students) in Senegal in 1972 to that in 1980?
Make the answer very short. 0.85. What is the ratio of the Female students (as % of total students) in Turkey in 1972 to that in 1980?
Your answer should be compact. 0.81. What is the ratio of the Female students (as % of total students) in Virgin Islands in 1972 to that in 1980?
Give a very brief answer. 1. What is the ratio of the Female students (as % of total students) in Senegal in 1973 to that in 1974?
Give a very brief answer. 1.12. What is the ratio of the Female students (as % of total students) of Turkey in 1973 to that in 1974?
Keep it short and to the point. 0.97. What is the ratio of the Female students (as % of total students) in Korea (Republic) in 1973 to that in 1977?
Offer a terse response. 0.95. What is the ratio of the Female students (as % of total students) of Senegal in 1973 to that in 1977?
Offer a very short reply. 0.87. What is the ratio of the Female students (as % of total students) of Turkey in 1973 to that in 1977?
Your response must be concise. 0.87. What is the ratio of the Female students (as % of total students) in Virgin Islands in 1973 to that in 1977?
Offer a terse response. 1. What is the ratio of the Female students (as % of total students) of Korea (Republic) in 1973 to that in 1978?
Make the answer very short. 0.94. What is the ratio of the Female students (as % of total students) of Senegal in 1973 to that in 1978?
Ensure brevity in your answer.  0.87. What is the ratio of the Female students (as % of total students) in Turkey in 1973 to that in 1978?
Provide a succinct answer. 0.87. What is the ratio of the Female students (as % of total students) in Virgin Islands in 1973 to that in 1978?
Offer a terse response. 1.01. What is the ratio of the Female students (as % of total students) of Korea (Republic) in 1973 to that in 1979?
Provide a succinct answer. 0.92. What is the ratio of the Female students (as % of total students) in Senegal in 1973 to that in 1979?
Your answer should be compact. 0.86. What is the ratio of the Female students (as % of total students) in Turkey in 1973 to that in 1979?
Give a very brief answer. 0.85. What is the ratio of the Female students (as % of total students) of Virgin Islands in 1973 to that in 1979?
Offer a terse response. 1. What is the ratio of the Female students (as % of total students) in Korea (Republic) in 1973 to that in 1980?
Offer a terse response. 0.9. What is the ratio of the Female students (as % of total students) of Senegal in 1973 to that in 1980?
Make the answer very short. 0.85. What is the ratio of the Female students (as % of total students) in Turkey in 1973 to that in 1980?
Offer a very short reply. 0.84. What is the ratio of the Female students (as % of total students) of Virgin Islands in 1973 to that in 1980?
Give a very brief answer. 1.01. What is the ratio of the Female students (as % of total students) in Korea (Republic) in 1974 to that in 1977?
Offer a very short reply. 0.96. What is the ratio of the Female students (as % of total students) of Senegal in 1974 to that in 1977?
Your answer should be compact. 0.78. What is the ratio of the Female students (as % of total students) in Turkey in 1974 to that in 1977?
Offer a terse response. 0.9. What is the ratio of the Female students (as % of total students) in Virgin Islands in 1974 to that in 1977?
Provide a short and direct response. 1. What is the ratio of the Female students (as % of total students) in Korea (Republic) in 1974 to that in 1978?
Keep it short and to the point. 0.94. What is the ratio of the Female students (as % of total students) of Senegal in 1974 to that in 1978?
Provide a succinct answer. 0.78. What is the ratio of the Female students (as % of total students) of Turkey in 1974 to that in 1978?
Your answer should be very brief. 0.89. What is the ratio of the Female students (as % of total students) in Korea (Republic) in 1974 to that in 1979?
Your response must be concise. 0.93. What is the ratio of the Female students (as % of total students) in Senegal in 1974 to that in 1979?
Give a very brief answer. 0.76. What is the ratio of the Female students (as % of total students) in Turkey in 1974 to that in 1979?
Offer a terse response. 0.87. What is the ratio of the Female students (as % of total students) in Virgin Islands in 1974 to that in 1979?
Give a very brief answer. 1. What is the ratio of the Female students (as % of total students) in Korea (Republic) in 1974 to that in 1980?
Keep it short and to the point. 0.91. What is the ratio of the Female students (as % of total students) of Senegal in 1974 to that in 1980?
Provide a succinct answer. 0.76. What is the ratio of the Female students (as % of total students) in Turkey in 1974 to that in 1980?
Give a very brief answer. 0.86. What is the ratio of the Female students (as % of total students) of Korea (Republic) in 1977 to that in 1978?
Offer a terse response. 0.99. What is the ratio of the Female students (as % of total students) of Senegal in 1977 to that in 1978?
Your answer should be very brief. 1. What is the ratio of the Female students (as % of total students) in Turkey in 1977 to that in 1978?
Ensure brevity in your answer.  0.99. What is the ratio of the Female students (as % of total students) of Virgin Islands in 1977 to that in 1978?
Offer a very short reply. 1.01. What is the ratio of the Female students (as % of total students) of Korea (Republic) in 1977 to that in 1979?
Ensure brevity in your answer.  0.97. What is the ratio of the Female students (as % of total students) in Senegal in 1977 to that in 1979?
Your answer should be compact. 0.98. What is the ratio of the Female students (as % of total students) of Turkey in 1977 to that in 1979?
Your answer should be very brief. 0.97. What is the ratio of the Female students (as % of total students) of Korea (Republic) in 1977 to that in 1980?
Ensure brevity in your answer.  0.95. What is the ratio of the Female students (as % of total students) of Senegal in 1977 to that in 1980?
Keep it short and to the point. 0.98. What is the ratio of the Female students (as % of total students) of Turkey in 1977 to that in 1980?
Your answer should be very brief. 0.96. What is the ratio of the Female students (as % of total students) in Korea (Republic) in 1978 to that in 1979?
Provide a short and direct response. 0.98. What is the ratio of the Female students (as % of total students) of Senegal in 1978 to that in 1979?
Your answer should be very brief. 0.98. What is the ratio of the Female students (as % of total students) in Turkey in 1978 to that in 1979?
Your answer should be compact. 0.98. What is the ratio of the Female students (as % of total students) of Korea (Republic) in 1978 to that in 1980?
Make the answer very short. 0.96. What is the ratio of the Female students (as % of total students) in Senegal in 1978 to that in 1980?
Ensure brevity in your answer.  0.98. What is the ratio of the Female students (as % of total students) in Turkey in 1978 to that in 1980?
Your answer should be compact. 0.96. What is the ratio of the Female students (as % of total students) of Virgin Islands in 1978 to that in 1980?
Provide a succinct answer. 1. What is the ratio of the Female students (as % of total students) in Korea (Republic) in 1979 to that in 1980?
Keep it short and to the point. 0.98. What is the ratio of the Female students (as % of total students) in Senegal in 1979 to that in 1980?
Ensure brevity in your answer.  0.99. What is the ratio of the Female students (as % of total students) of Turkey in 1979 to that in 1980?
Your answer should be compact. 0.99. What is the difference between the highest and the second highest Female students (as % of total students) of Korea (Republic)?
Give a very brief answer. 0.99. What is the difference between the highest and the second highest Female students (as % of total students) of Senegal?
Provide a short and direct response. 0.21. What is the difference between the highest and the second highest Female students (as % of total students) in Turkey?
Your response must be concise. 0.48. What is the difference between the highest and the second highest Female students (as % of total students) in Virgin Islands?
Your answer should be very brief. 0. What is the difference between the highest and the lowest Female students (as % of total students) in Korea (Republic)?
Offer a terse response. 4.93. What is the difference between the highest and the lowest Female students (as % of total students) in Senegal?
Keep it short and to the point. 8.07. What is the difference between the highest and the lowest Female students (as % of total students) in Turkey?
Provide a succinct answer. 6.41. What is the difference between the highest and the lowest Female students (as % of total students) of Virgin Islands?
Provide a succinct answer. 0.3. 